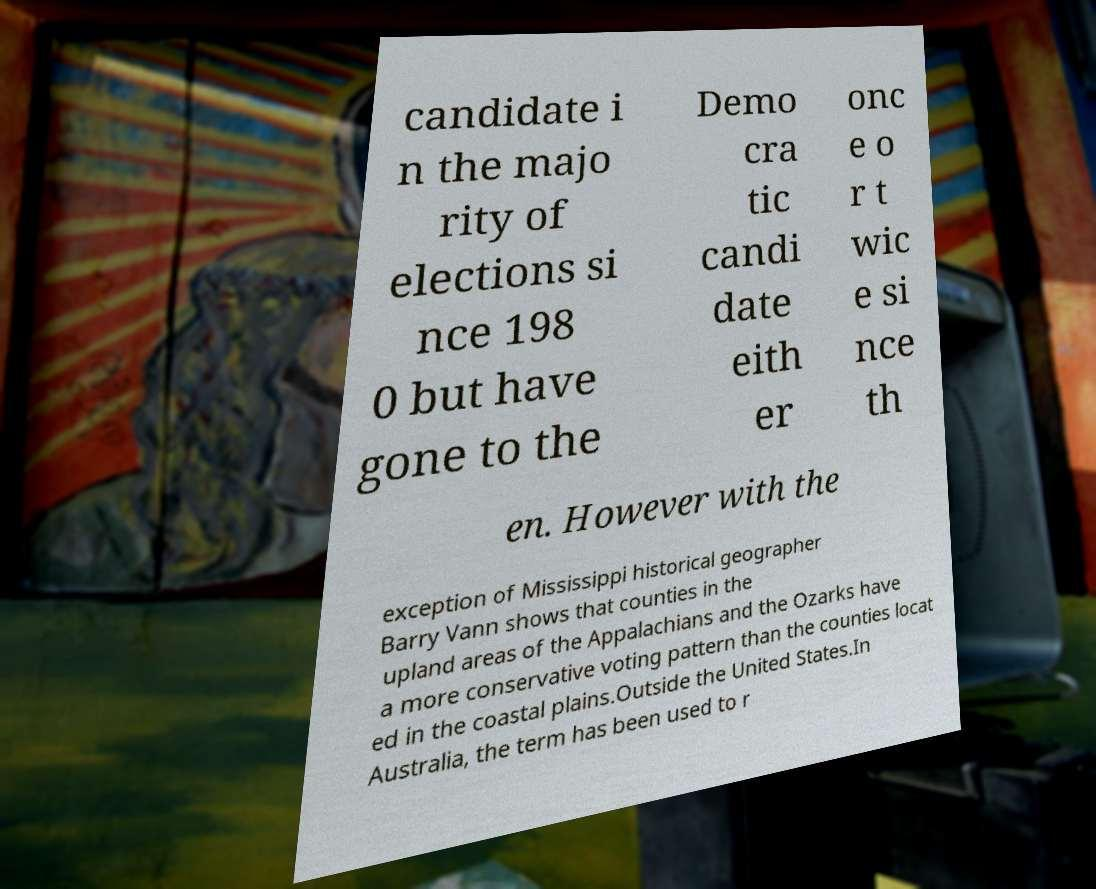I need the written content from this picture converted into text. Can you do that? candidate i n the majo rity of elections si nce 198 0 but have gone to the Demo cra tic candi date eith er onc e o r t wic e si nce th en. However with the exception of Mississippi historical geographer Barry Vann shows that counties in the upland areas of the Appalachians and the Ozarks have a more conservative voting pattern than the counties locat ed in the coastal plains.Outside the United States.In Australia, the term has been used to r 